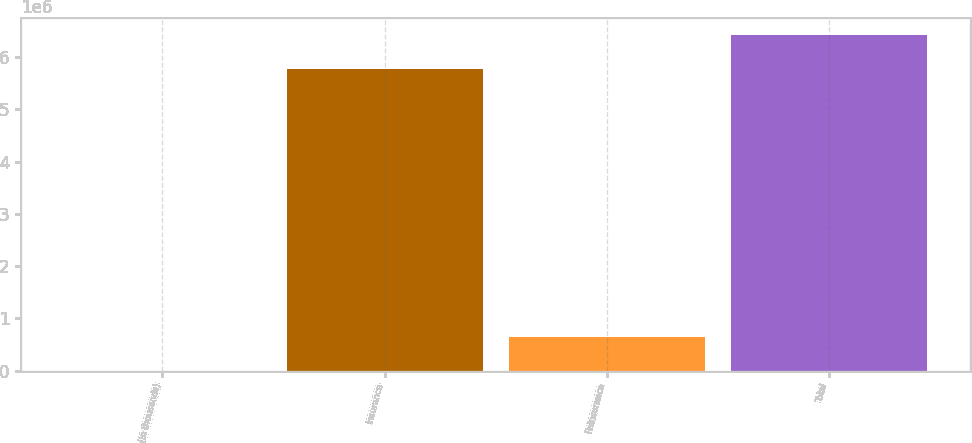Convert chart. <chart><loc_0><loc_0><loc_500><loc_500><bar_chart><fcel>(In thousands)<fcel>Insurance<fcel>Reinsurance<fcel>Total<nl><fcel>2016<fcel>5.77591e+06<fcel>648000<fcel>6.42391e+06<nl></chart> 